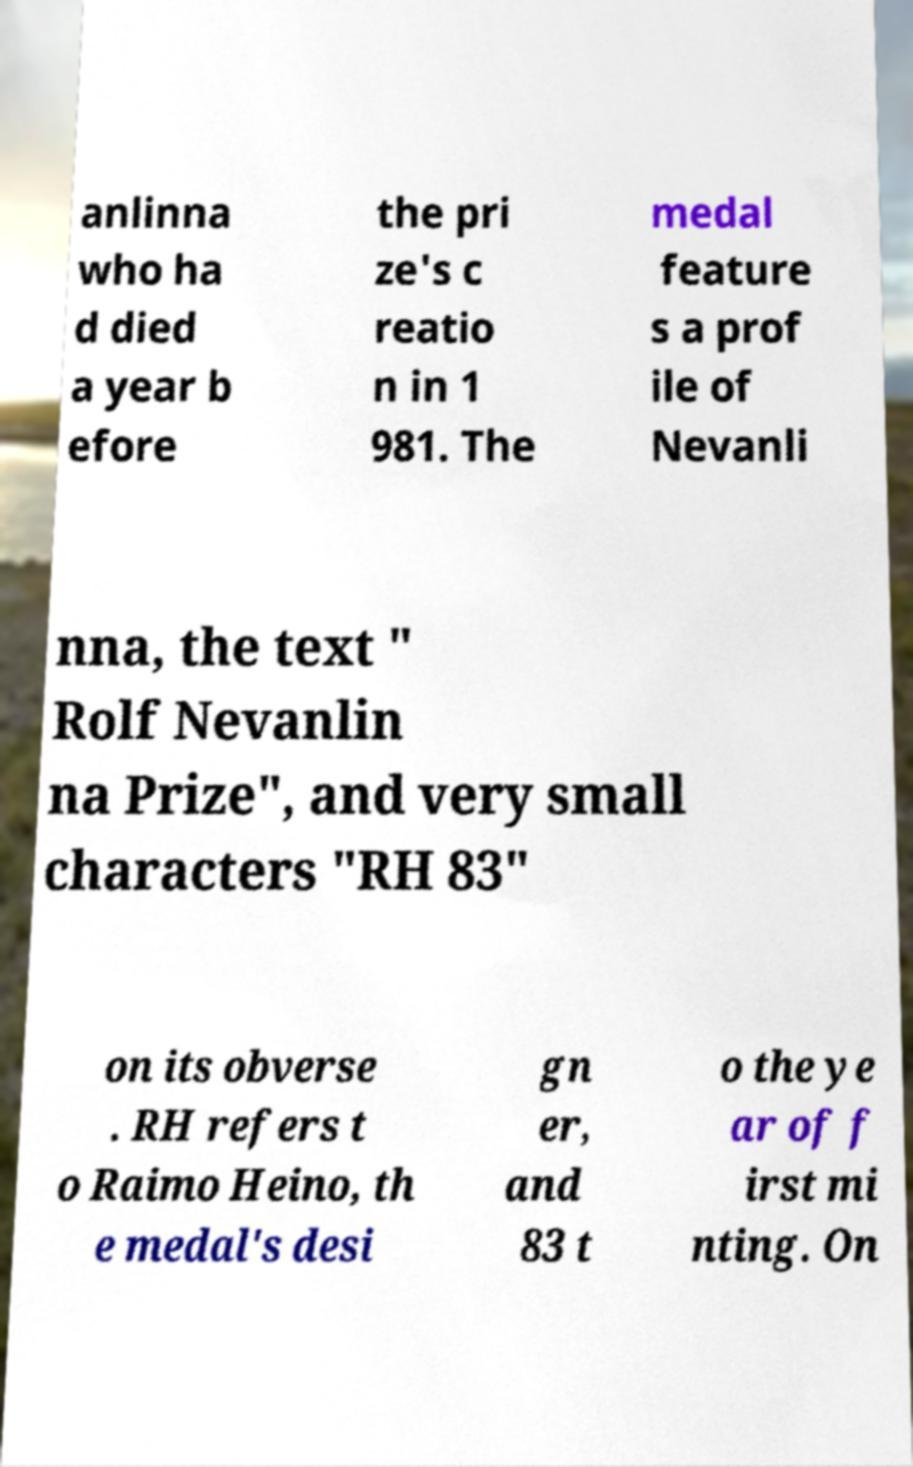What messages or text are displayed in this image? I need them in a readable, typed format. anlinna who ha d died a year b efore the pri ze's c reatio n in 1 981. The medal feature s a prof ile of Nevanli nna, the text " Rolf Nevanlin na Prize", and very small characters "RH 83" on its obverse . RH refers t o Raimo Heino, th e medal's desi gn er, and 83 t o the ye ar of f irst mi nting. On 